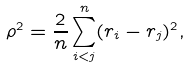Convert formula to latex. <formula><loc_0><loc_0><loc_500><loc_500>\rho ^ { 2 } = \frac { 2 } { n } \sum _ { i < j } ^ { n } ( { r } _ { i } - { r } _ { j } ) ^ { 2 } ,</formula> 